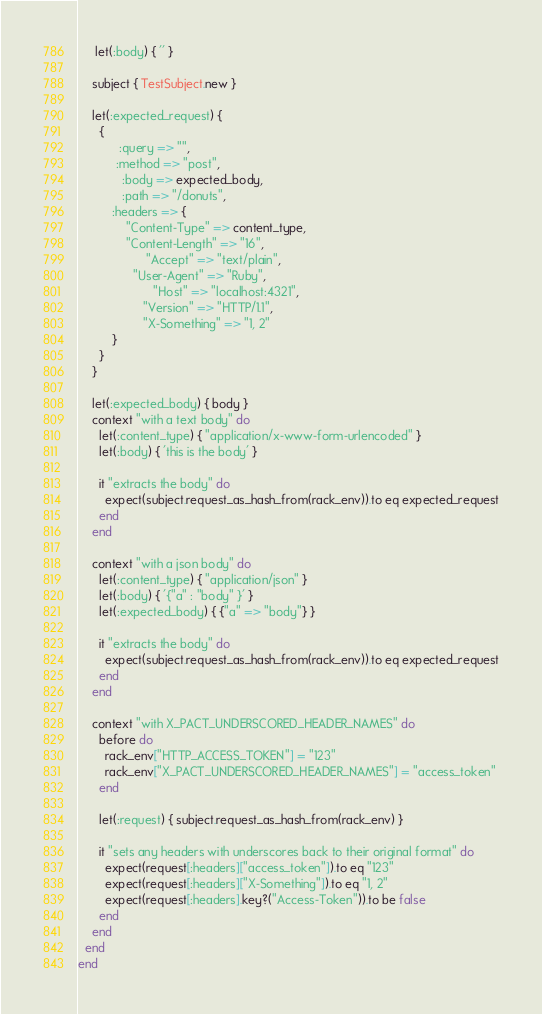<code> <loc_0><loc_0><loc_500><loc_500><_Ruby_>     let(:body) { '' }

    subject { TestSubject.new }

    let(:expected_request) {
      {
            :query => "",
           :method => "post",
             :body => expected_body,
             :path => "/donuts",
          :headers => {
              "Content-Type" => content_type,
              "Content-Length" => "16",
                    "Accept" => "text/plain",
                "User-Agent" => "Ruby",
                      "Host" => "localhost:4321",
                   "Version" => "HTTP/1.1",
                   "X-Something" => "1, 2"
          }
      }
    }

    let(:expected_body) { body }
    context "with a text body" do
      let(:content_type) { "application/x-www-form-urlencoded" }
      let(:body) { 'this is the body' }

      it "extracts the body" do
        expect(subject.request_as_hash_from(rack_env)).to eq expected_request
      end
    end

    context "with a json body" do
      let(:content_type) { "application/json" }
      let(:body) { '{"a" : "body" }' }
      let(:expected_body) { {"a" => "body"} }

      it "extracts the body" do
        expect(subject.request_as_hash_from(rack_env)).to eq expected_request
      end
    end

    context "with X_PACT_UNDERSCORED_HEADER_NAMES" do
      before do
        rack_env["HTTP_ACCESS_TOKEN"] = "123"
        rack_env["X_PACT_UNDERSCORED_HEADER_NAMES"] = "access_token"
      end

      let(:request) { subject.request_as_hash_from(rack_env) }

      it "sets any headers with underscores back to their original format" do
        expect(request[:headers]["access_token"]).to eq "123"
        expect(request[:headers]["X-Something"]).to eq "1, 2"
        expect(request[:headers].key?("Access-Token")).to be false
      end
    end
  end
end
</code> 